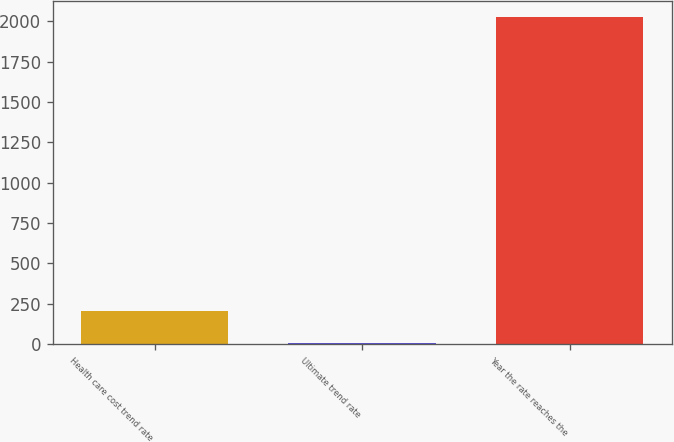Convert chart to OTSL. <chart><loc_0><loc_0><loc_500><loc_500><bar_chart><fcel>Health care cost trend rate<fcel>Ultimate trend rate<fcel>Year the rate reaches the<nl><fcel>206.65<fcel>4.5<fcel>2026<nl></chart> 